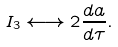Convert formula to latex. <formula><loc_0><loc_0><loc_500><loc_500>I _ { 3 } \longleftrightarrow 2 \frac { d a } { d \tau } .</formula> 